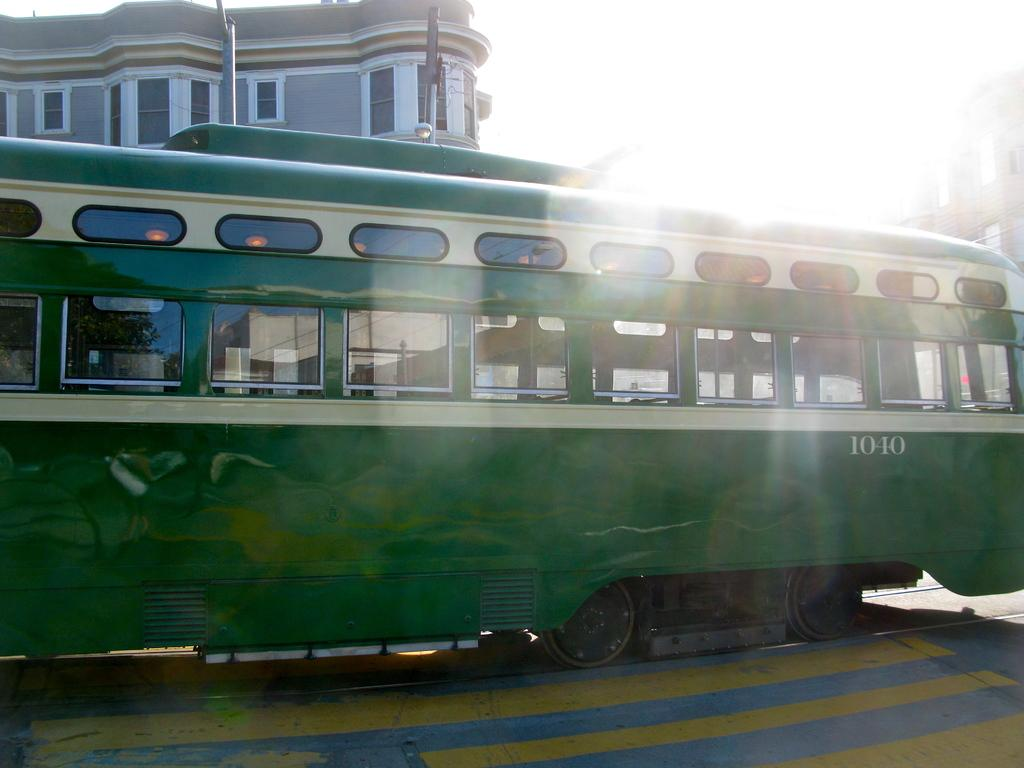What is the main subject of the image? The main subject of the image is a tram. Where is the tram located in the image? The tram is in the middle of the image. What can be seen in the background of the image? There is a building in the background of the image. What is visible at the top of the image? The sky is visible at the top of the image. How many eggs are visible on the hill in the image? There is no hill or eggs present in the image. 